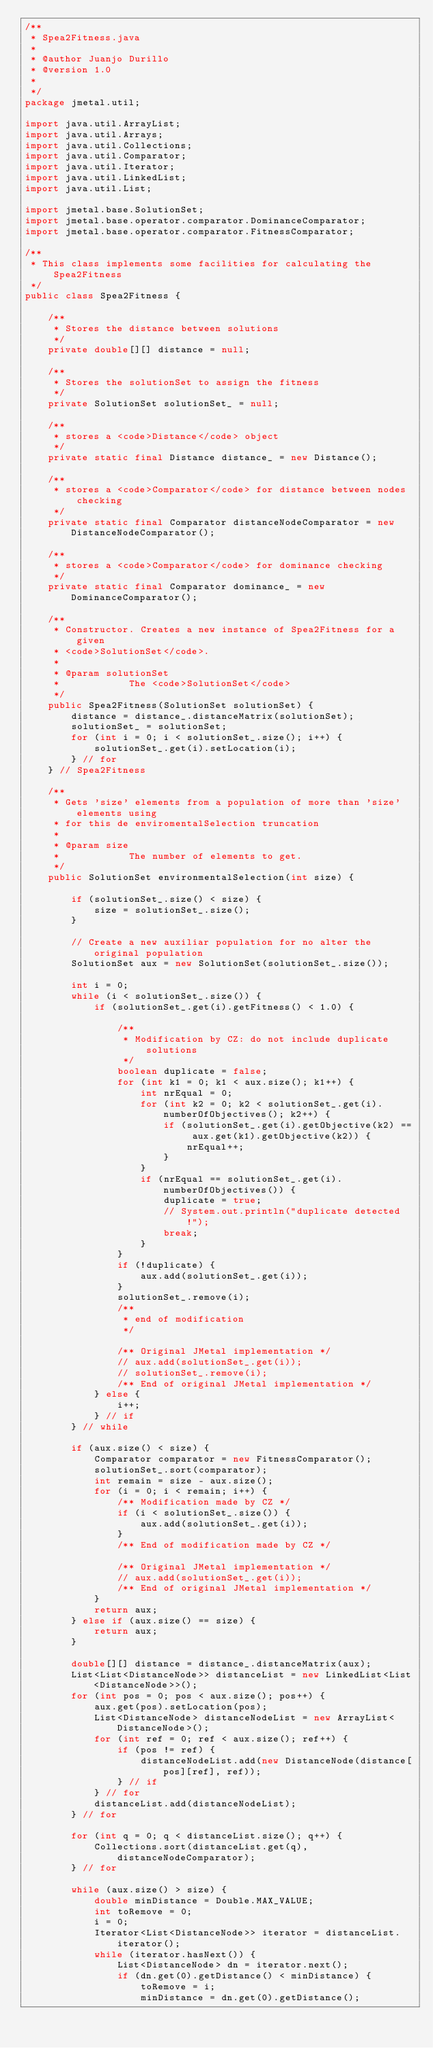<code> <loc_0><loc_0><loc_500><loc_500><_Java_>/**
 * Spea2Fitness.java
 *
 * @author Juanjo Durillo
 * @version 1.0
 *
 */
package jmetal.util;

import java.util.ArrayList;
import java.util.Arrays;
import java.util.Collections;
import java.util.Comparator;
import java.util.Iterator;
import java.util.LinkedList;
import java.util.List;

import jmetal.base.SolutionSet;
import jmetal.base.operator.comparator.DominanceComparator;
import jmetal.base.operator.comparator.FitnessComparator;

/**
 * This class implements some facilities for calculating the Spea2Fitness
 */
public class Spea2Fitness {

	/**
	 * Stores the distance between solutions
	 */
	private double[][] distance = null;

	/**
	 * Stores the solutionSet to assign the fitness
	 */
	private SolutionSet solutionSet_ = null;

	/**
	 * stores a <code>Distance</code> object
	 */
	private static final Distance distance_ = new Distance();

	/**
	 * stores a <code>Comparator</code> for distance between nodes checking
	 */
	private static final Comparator distanceNodeComparator = new DistanceNodeComparator();

	/**
	 * stores a <code>Comparator</code> for dominance checking
	 */
	private static final Comparator dominance_ = new DominanceComparator();

	/**
	 * Constructor. Creates a new instance of Spea2Fitness for a given
	 * <code>SolutionSet</code>.
	 * 
	 * @param solutionSet
	 *            The <code>SolutionSet</code>
	 */
	public Spea2Fitness(SolutionSet solutionSet) {
		distance = distance_.distanceMatrix(solutionSet);
		solutionSet_ = solutionSet;
		for (int i = 0; i < solutionSet_.size(); i++) {
			solutionSet_.get(i).setLocation(i);
		} // for
	} // Spea2Fitness

	/**
	 * Gets 'size' elements from a population of more than 'size' elements using
	 * for this de enviromentalSelection truncation
	 * 
	 * @param size
	 *            The number of elements to get.
	 */
	public SolutionSet environmentalSelection(int size) {

		if (solutionSet_.size() < size) {
			size = solutionSet_.size();
		}

		// Create a new auxiliar population for no alter the original population
		SolutionSet aux = new SolutionSet(solutionSet_.size());

		int i = 0;
		while (i < solutionSet_.size()) {
			if (solutionSet_.get(i).getFitness() < 1.0) {

				/**
				 * Modification by CZ: do not include duplicate solutions
				 */
				boolean duplicate = false;
				for (int k1 = 0; k1 < aux.size(); k1++) {
					int nrEqual = 0;
					for (int k2 = 0; k2 < solutionSet_.get(i).numberOfObjectives(); k2++) {
						if (solutionSet_.get(i).getObjective(k2) == aux.get(k1).getObjective(k2)) {
							nrEqual++;
						}
					}
					if (nrEqual == solutionSet_.get(i).numberOfObjectives()) {
						duplicate = true;
						// System.out.println("duplicate detected!");
						break;
					}
				}
				if (!duplicate) {
					aux.add(solutionSet_.get(i));
				}
				solutionSet_.remove(i);
				/**
				 * end of modification
				 */

				/** Original JMetal implementation */
				// aux.add(solutionSet_.get(i));
				// solutionSet_.remove(i);
				/** End of original JMetal implementation */
			} else {
				i++;
			} // if
		} // while

		if (aux.size() < size) {
			Comparator comparator = new FitnessComparator();
			solutionSet_.sort(comparator);
			int remain = size - aux.size();
			for (i = 0; i < remain; i++) {
				/** Modification made by CZ */
				if (i < solutionSet_.size()) {
					aux.add(solutionSet_.get(i));
				}
				/** End of modification made by CZ */

				/** Original JMetal implementation */
				// aux.add(solutionSet_.get(i));
				/** End of original JMetal implementation */
			}
			return aux;
		} else if (aux.size() == size) {
			return aux;
		}

		double[][] distance = distance_.distanceMatrix(aux);
		List<List<DistanceNode>> distanceList = new LinkedList<List<DistanceNode>>();
		for (int pos = 0; pos < aux.size(); pos++) {
			aux.get(pos).setLocation(pos);
			List<DistanceNode> distanceNodeList = new ArrayList<DistanceNode>();
			for (int ref = 0; ref < aux.size(); ref++) {
				if (pos != ref) {
					distanceNodeList.add(new DistanceNode(distance[pos][ref], ref));
				} // if
			} // for
			distanceList.add(distanceNodeList);
		} // for

		for (int q = 0; q < distanceList.size(); q++) {
			Collections.sort(distanceList.get(q), distanceNodeComparator);
		} // for

		while (aux.size() > size) {
			double minDistance = Double.MAX_VALUE;
			int toRemove = 0;
			i = 0;
			Iterator<List<DistanceNode>> iterator = distanceList.iterator();
			while (iterator.hasNext()) {
				List<DistanceNode> dn = iterator.next();
				if (dn.get(0).getDistance() < minDistance) {
					toRemove = i;
					minDistance = dn.get(0).getDistance();</code> 